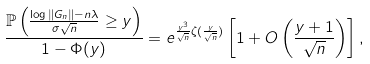Convert formula to latex. <formula><loc_0><loc_0><loc_500><loc_500>\frac { \mathbb { P } \left ( \frac { \log \| G _ { n } \| - n \lambda } { \sigma \sqrt { n } } \geq y \right ) } { 1 - \Phi ( y ) } = e ^ { \frac { y ^ { 3 } } { \sqrt { n } } \zeta ( \frac { y } { \sqrt { n } } ) } \left [ 1 + O \left ( \frac { y + 1 } { \sqrt { n } } \right ) \right ] ,</formula> 